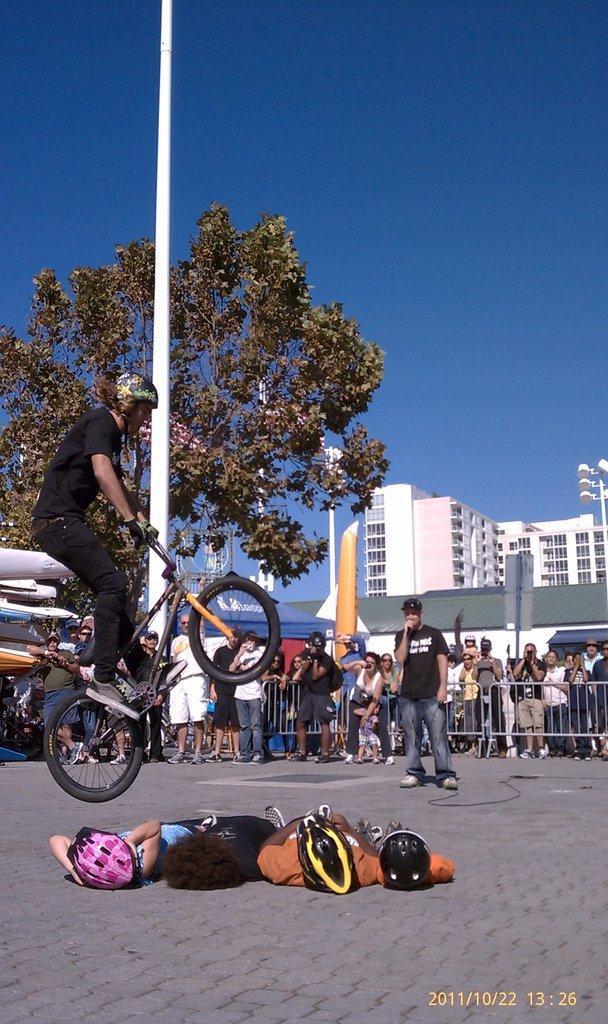Could you give a brief overview of what you see in this image? An outdoor picture. This is a pole. This is tree. Far there is a building with windows. The persons are standing. This man is riding a bicycle. This persons are laying on floor wore helmet. 